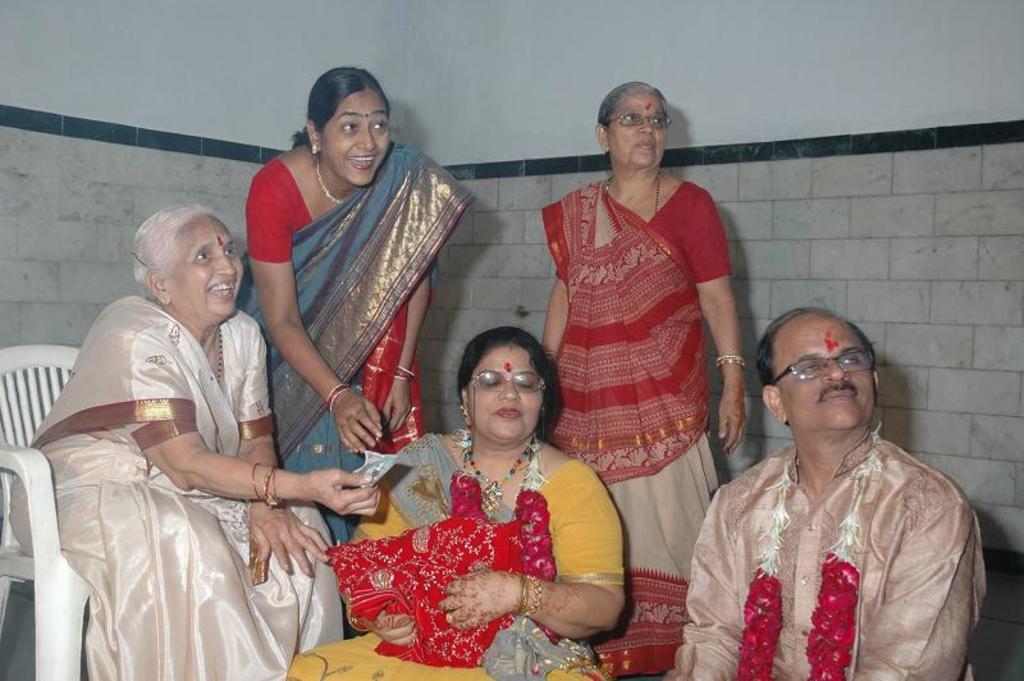Please provide a concise description of this image. These three people sitting and these two women standing and this woman holding cloth. Background we can see wall. 